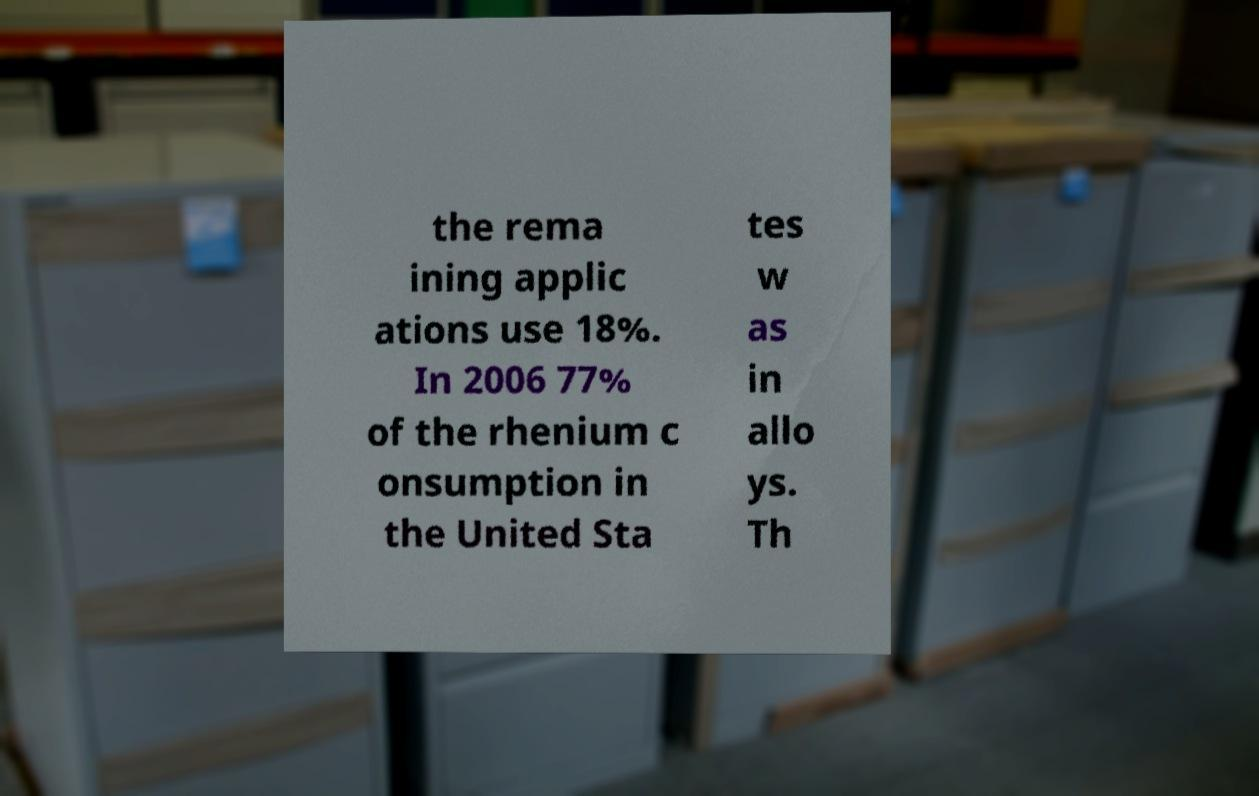Please read and relay the text visible in this image. What does it say? the rema ining applic ations use 18%. In 2006 77% of the rhenium c onsumption in the United Sta tes w as in allo ys. Th 